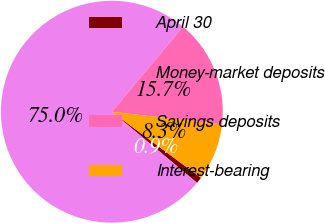<chart> <loc_0><loc_0><loc_500><loc_500><pie_chart><fcel>April 30<fcel>Money-market deposits<fcel>Savings deposits<fcel>Interest-bearing<nl><fcel>0.92%<fcel>75.02%<fcel>15.74%<fcel>8.33%<nl></chart> 